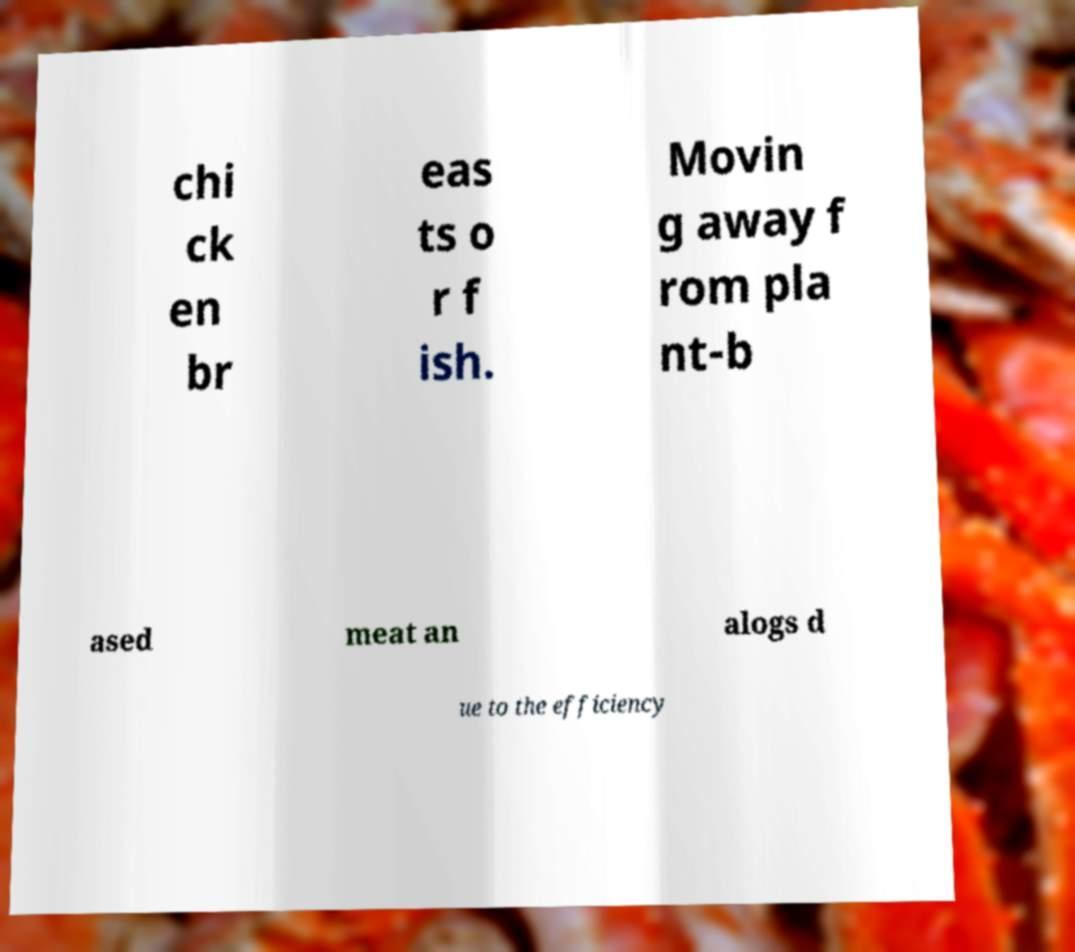Please read and relay the text visible in this image. What does it say? chi ck en br eas ts o r f ish. Movin g away f rom pla nt-b ased meat an alogs d ue to the efficiency 